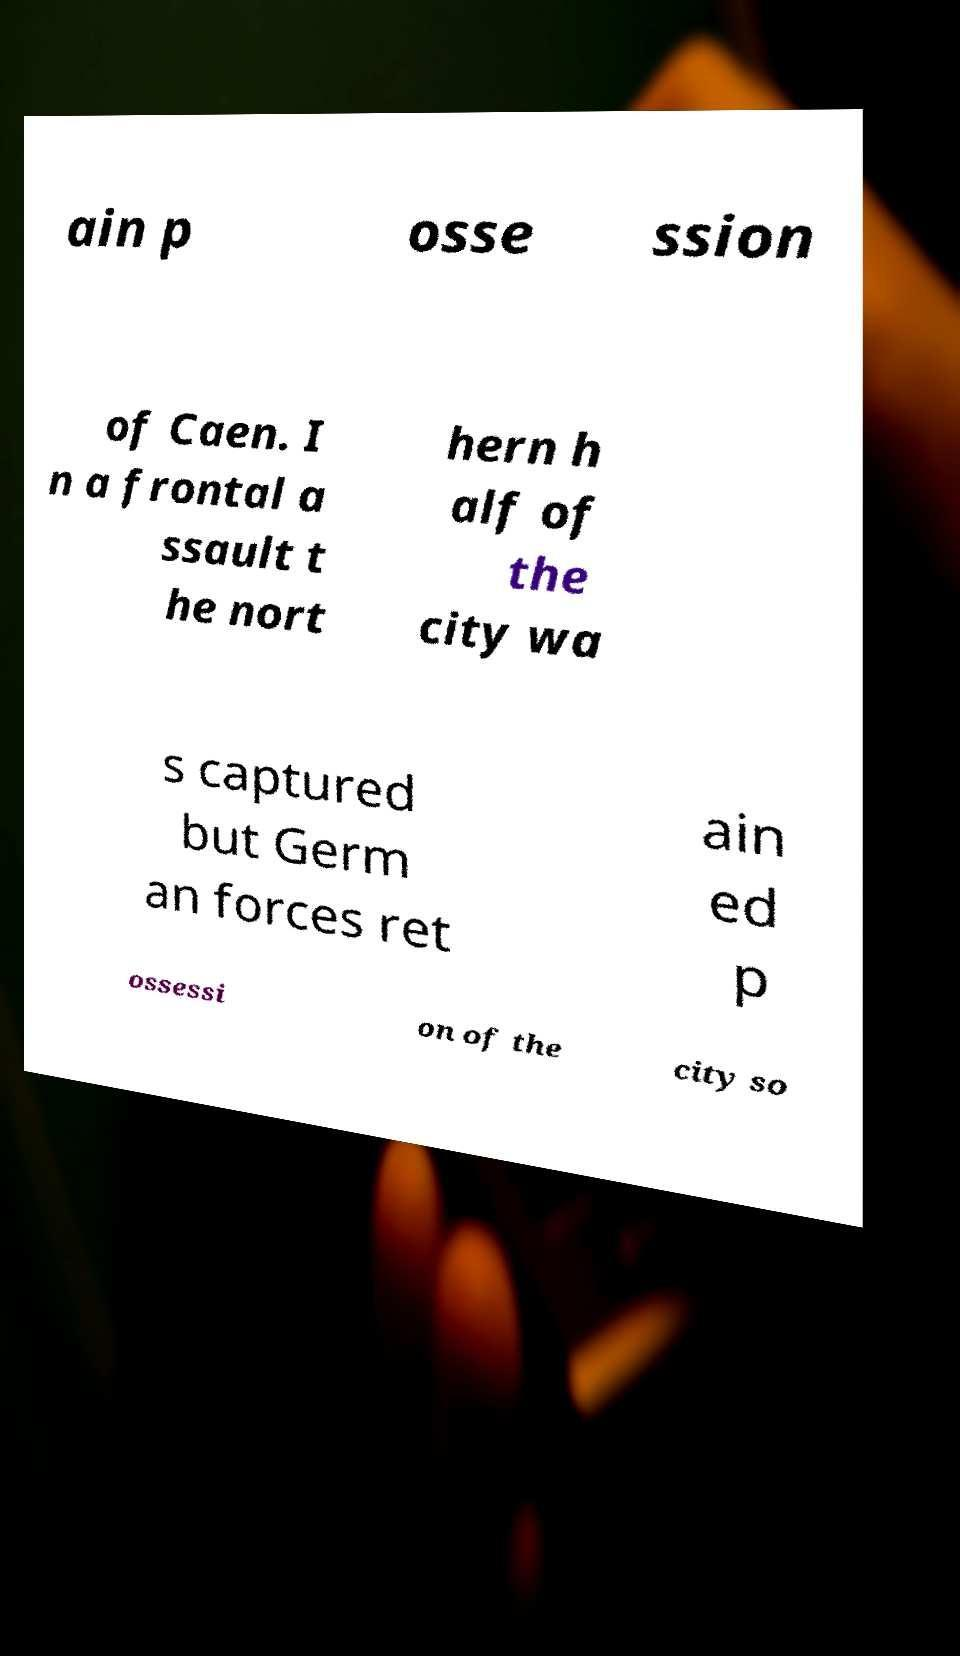Could you assist in decoding the text presented in this image and type it out clearly? ain p osse ssion of Caen. I n a frontal a ssault t he nort hern h alf of the city wa s captured but Germ an forces ret ain ed p ossessi on of the city so 